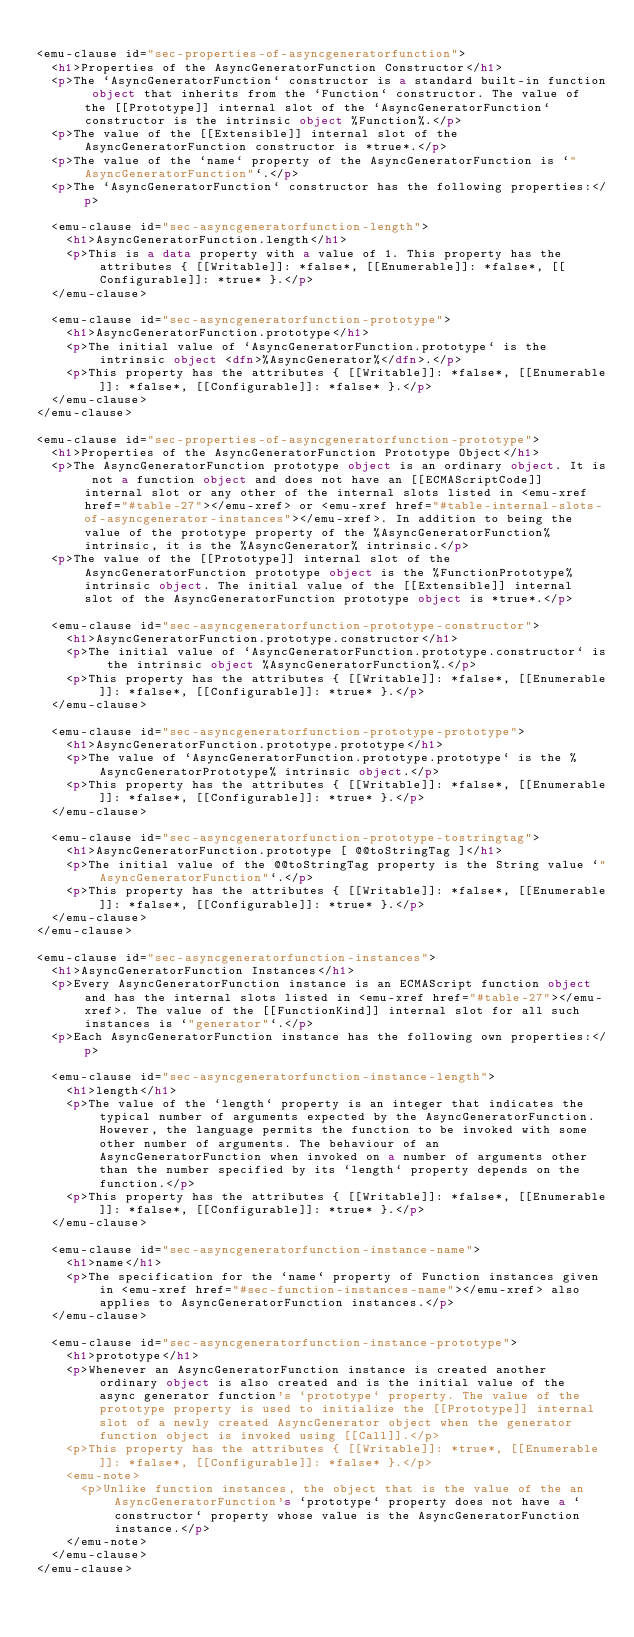<code> <loc_0><loc_0><loc_500><loc_500><_HTML_>
<emu-clause id="sec-properties-of-asyncgeneratorfunction">
  <h1>Properties of the AsyncGeneratorFunction Constructor</h1>
  <p>The `AsyncGeneratorFunction` constructor is a standard built-in function object that inherits from the `Function` constructor. The value of the [[Prototype]] internal slot of the `AsyncGeneratorFunction` constructor is the intrinsic object %Function%.</p>
  <p>The value of the [[Extensible]] internal slot of the AsyncGeneratorFunction constructor is *true*.</p>
  <p>The value of the `name` property of the AsyncGeneratorFunction is `"AsyncGeneratorFunction"`.</p>
  <p>The `AsyncGeneratorFunction` constructor has the following properties:</p>

  <emu-clause id="sec-asyncgeneratorfunction-length">
    <h1>AsyncGeneratorFunction.length</h1>
    <p>This is a data property with a value of 1. This property has the attributes { [[Writable]]: *false*, [[Enumerable]]: *false*, [[Configurable]]: *true* }.</p>
  </emu-clause>

  <emu-clause id="sec-asyncgeneratorfunction-prototype">
    <h1>AsyncGeneratorFunction.prototype</h1>
    <p>The initial value of `AsyncGeneratorFunction.prototype` is the intrinsic object <dfn>%AsyncGenerator%</dfn>.</p>
    <p>This property has the attributes { [[Writable]]: *false*, [[Enumerable]]: *false*, [[Configurable]]: *false* }.</p>
  </emu-clause>
</emu-clause>

<emu-clause id="sec-properties-of-asyncgeneratorfunction-prototype">
  <h1>Properties of the AsyncGeneratorFunction Prototype Object</h1>
  <p>The AsyncGeneratorFunction prototype object is an ordinary object. It is not a function object and does not have an [[ECMAScriptCode]] internal slot or any other of the internal slots listed in <emu-xref href="#table-27"></emu-xref> or <emu-xref href="#table-internal-slots-of-asyncgenerator-instances"></emu-xref>. In addition to being the value of the prototype property of the %AsyncGeneratorFunction% intrinsic, it is the %AsyncGenerator% intrinsic.</p>
  <p>The value of the [[Prototype]] internal slot of the AsyncGeneratorFunction prototype object is the %FunctionPrototype% intrinsic object. The initial value of the [[Extensible]] internal slot of the AsyncGeneratorFunction prototype object is *true*.</p>

  <emu-clause id="sec-asyncgeneratorfunction-prototype-constructor">
    <h1>AsyncGeneratorFunction.prototype.constructor</h1>
    <p>The initial value of `AsyncGeneratorFunction.prototype.constructor` is the intrinsic object %AsyncGeneratorFunction%.</p>
    <p>This property has the attributes { [[Writable]]: *false*, [[Enumerable]]: *false*, [[Configurable]]: *true* }.</p>
  </emu-clause>

  <emu-clause id="sec-asyncgeneratorfunction-prototype-prototype">
    <h1>AsyncGeneratorFunction.prototype.prototype</h1>
    <p>The value of `AsyncGeneratorFunction.prototype.prototype` is the %AsyncGeneratorPrototype% intrinsic object.</p>
    <p>This property has the attributes { [[Writable]]: *false*, [[Enumerable]]: *false*, [[Configurable]]: *true* }.</p>
  </emu-clause>

  <emu-clause id="sec-asyncgeneratorfunction-prototype-tostringtag">
    <h1>AsyncGeneratorFunction.prototype [ @@toStringTag ]</h1>
    <p>The initial value of the @@toStringTag property is the String value `"AsyncGeneratorFunction"`.</p>
    <p>This property has the attributes { [[Writable]]: *false*, [[Enumerable]]: *false*, [[Configurable]]: *true* }.</p>
  </emu-clause>
</emu-clause>

<emu-clause id="sec-asyncgeneratorfunction-instances">
  <h1>AsyncGeneratorFunction Instances</h1>
  <p>Every AsyncGeneratorFunction instance is an ECMAScript function object and has the internal slots listed in <emu-xref href="#table-27"></emu-xref>. The value of the [[FunctionKind]] internal slot for all such instances is `"generator"`.</p>
  <p>Each AsyncGeneratorFunction instance has the following own properties:</p>

  <emu-clause id="sec-asyncgeneratorfunction-instance-length">
    <h1>length</h1>
    <p>The value of the `length` property is an integer that indicates the typical number of arguments expected by the AsyncGeneratorFunction. However, the language permits the function to be invoked with some other number of arguments. The behaviour of an AsyncGeneratorFunction when invoked on a number of arguments other than the number specified by its `length` property depends on the function.</p>
    <p>This property has the attributes { [[Writable]]: *false*, [[Enumerable]]: *false*, [[Configurable]]: *true* }.</p>
  </emu-clause>

  <emu-clause id="sec-asyncgeneratorfunction-instance-name">
    <h1>name</h1>
    <p>The specification for the `name` property of Function instances given in <emu-xref href="#sec-function-instances-name"></emu-xref> also applies to AsyncGeneratorFunction instances.</p>
  </emu-clause>

  <emu-clause id="sec-asyncgeneratorfunction-instance-prototype">
    <h1>prototype</h1>
    <p>Whenever an AsyncGeneratorFunction instance is created another ordinary object is also created and is the initial value of the async generator function's `prototype` property. The value of the prototype property is used to initialize the [[Prototype]] internal slot of a newly created AsyncGenerator object when the generator function object is invoked using [[Call]].</p>
    <p>This property has the attributes { [[Writable]]: *true*, [[Enumerable]]: *false*, [[Configurable]]: *false* }.</p>
    <emu-note>
      <p>Unlike function instances, the object that is the value of the an AsyncGeneratorFunction's `prototype` property does not have a `constructor` property whose value is the AsyncGeneratorFunction instance.</p>
    </emu-note>
  </emu-clause>
</emu-clause>
</code> 